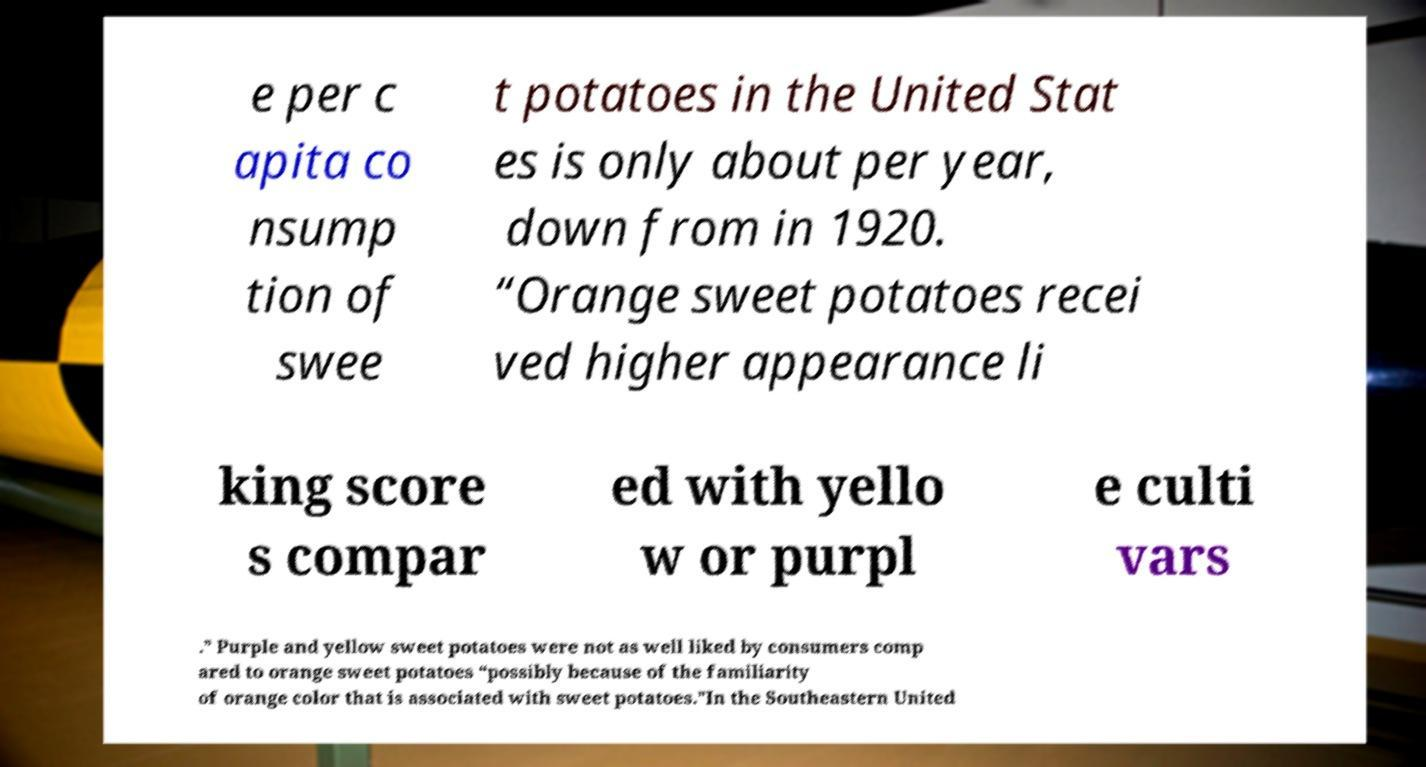There's text embedded in this image that I need extracted. Can you transcribe it verbatim? e per c apita co nsump tion of swee t potatoes in the United Stat es is only about per year, down from in 1920. “Orange sweet potatoes recei ved higher appearance li king score s compar ed with yello w or purpl e culti vars .” Purple and yellow sweet potatoes were not as well liked by consumers comp ared to orange sweet potatoes “possibly because of the familiarity of orange color that is associated with sweet potatoes.”In the Southeastern United 